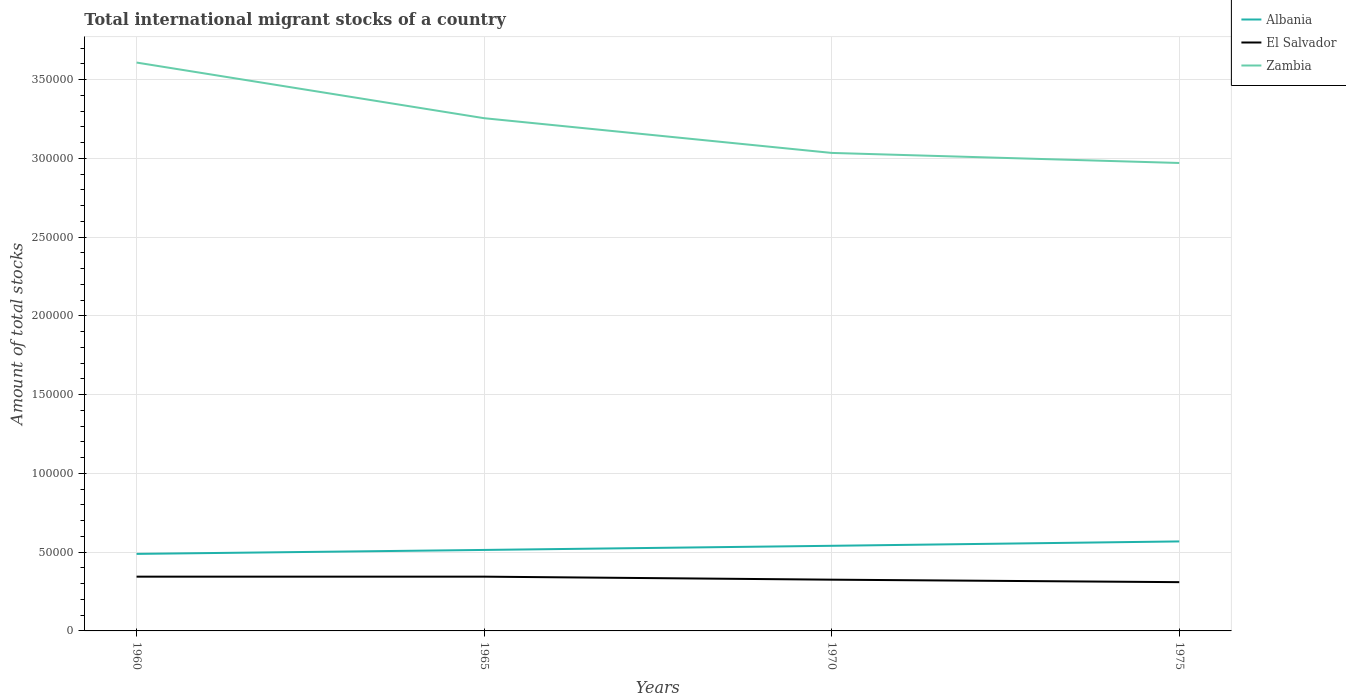How many different coloured lines are there?
Offer a terse response. 3. Does the line corresponding to Zambia intersect with the line corresponding to El Salvador?
Ensure brevity in your answer.  No. Across all years, what is the maximum amount of total stocks in in Zambia?
Offer a terse response. 2.97e+05. In which year was the amount of total stocks in in Zambia maximum?
Your response must be concise. 1975. What is the total amount of total stocks in in Zambia in the graph?
Offer a very short reply. 2.20e+04. What is the difference between the highest and the second highest amount of total stocks in in Zambia?
Offer a terse response. 6.38e+04. What is the difference between the highest and the lowest amount of total stocks in in Albania?
Make the answer very short. 2. Is the amount of total stocks in in Zambia strictly greater than the amount of total stocks in in El Salvador over the years?
Your answer should be compact. No. Does the graph contain any zero values?
Ensure brevity in your answer.  No. What is the title of the graph?
Your answer should be compact. Total international migrant stocks of a country. What is the label or title of the Y-axis?
Provide a succinct answer. Amount of total stocks. What is the Amount of total stocks in Albania in 1960?
Keep it short and to the point. 4.89e+04. What is the Amount of total stocks in El Salvador in 1960?
Provide a short and direct response. 3.44e+04. What is the Amount of total stocks of Zambia in 1960?
Your answer should be compact. 3.61e+05. What is the Amount of total stocks in Albania in 1965?
Provide a short and direct response. 5.14e+04. What is the Amount of total stocks of El Salvador in 1965?
Provide a succinct answer. 3.45e+04. What is the Amount of total stocks of Zambia in 1965?
Provide a succinct answer. 3.26e+05. What is the Amount of total stocks in Albania in 1970?
Offer a terse response. 5.40e+04. What is the Amount of total stocks of El Salvador in 1970?
Make the answer very short. 3.25e+04. What is the Amount of total stocks in Zambia in 1970?
Provide a short and direct response. 3.03e+05. What is the Amount of total stocks in Albania in 1975?
Your response must be concise. 5.68e+04. What is the Amount of total stocks in El Salvador in 1975?
Your answer should be compact. 3.10e+04. What is the Amount of total stocks of Zambia in 1975?
Ensure brevity in your answer.  2.97e+05. Across all years, what is the maximum Amount of total stocks in Albania?
Keep it short and to the point. 5.68e+04. Across all years, what is the maximum Amount of total stocks in El Salvador?
Offer a terse response. 3.45e+04. Across all years, what is the maximum Amount of total stocks in Zambia?
Your answer should be very brief. 3.61e+05. Across all years, what is the minimum Amount of total stocks in Albania?
Your response must be concise. 4.89e+04. Across all years, what is the minimum Amount of total stocks of El Salvador?
Provide a short and direct response. 3.10e+04. Across all years, what is the minimum Amount of total stocks in Zambia?
Give a very brief answer. 2.97e+05. What is the total Amount of total stocks in Albania in the graph?
Give a very brief answer. 2.11e+05. What is the total Amount of total stocks in El Salvador in the graph?
Offer a terse response. 1.32e+05. What is the total Amount of total stocks of Zambia in the graph?
Keep it short and to the point. 1.29e+06. What is the difference between the Amount of total stocks in Albania in 1960 and that in 1965?
Offer a terse response. -2508. What is the difference between the Amount of total stocks of Zambia in 1960 and that in 1965?
Make the answer very short. 3.53e+04. What is the difference between the Amount of total stocks in Albania in 1960 and that in 1970?
Make the answer very short. -5144. What is the difference between the Amount of total stocks in El Salvador in 1960 and that in 1970?
Keep it short and to the point. 1912. What is the difference between the Amount of total stocks of Zambia in 1960 and that in 1970?
Provide a short and direct response. 5.74e+04. What is the difference between the Amount of total stocks of Albania in 1960 and that in 1975?
Offer a terse response. -7915. What is the difference between the Amount of total stocks in El Salvador in 1960 and that in 1975?
Offer a very short reply. 3483. What is the difference between the Amount of total stocks of Zambia in 1960 and that in 1975?
Your answer should be compact. 6.38e+04. What is the difference between the Amount of total stocks in Albania in 1965 and that in 1970?
Make the answer very short. -2636. What is the difference between the Amount of total stocks of El Salvador in 1965 and that in 1970?
Your response must be concise. 1919. What is the difference between the Amount of total stocks of Zambia in 1965 and that in 1970?
Your answer should be compact. 2.20e+04. What is the difference between the Amount of total stocks of Albania in 1965 and that in 1975?
Offer a very short reply. -5407. What is the difference between the Amount of total stocks in El Salvador in 1965 and that in 1975?
Make the answer very short. 3490. What is the difference between the Amount of total stocks in Zambia in 1965 and that in 1975?
Your response must be concise. 2.84e+04. What is the difference between the Amount of total stocks of Albania in 1970 and that in 1975?
Your answer should be very brief. -2771. What is the difference between the Amount of total stocks of El Salvador in 1970 and that in 1975?
Make the answer very short. 1571. What is the difference between the Amount of total stocks in Zambia in 1970 and that in 1975?
Ensure brevity in your answer.  6393. What is the difference between the Amount of total stocks of Albania in 1960 and the Amount of total stocks of El Salvador in 1965?
Keep it short and to the point. 1.44e+04. What is the difference between the Amount of total stocks of Albania in 1960 and the Amount of total stocks of Zambia in 1965?
Provide a succinct answer. -2.77e+05. What is the difference between the Amount of total stocks of El Salvador in 1960 and the Amount of total stocks of Zambia in 1965?
Your response must be concise. -2.91e+05. What is the difference between the Amount of total stocks of Albania in 1960 and the Amount of total stocks of El Salvador in 1970?
Offer a very short reply. 1.64e+04. What is the difference between the Amount of total stocks in Albania in 1960 and the Amount of total stocks in Zambia in 1970?
Offer a very short reply. -2.55e+05. What is the difference between the Amount of total stocks of El Salvador in 1960 and the Amount of total stocks of Zambia in 1970?
Keep it short and to the point. -2.69e+05. What is the difference between the Amount of total stocks of Albania in 1960 and the Amount of total stocks of El Salvador in 1975?
Provide a succinct answer. 1.79e+04. What is the difference between the Amount of total stocks in Albania in 1960 and the Amount of total stocks in Zambia in 1975?
Your response must be concise. -2.48e+05. What is the difference between the Amount of total stocks of El Salvador in 1960 and the Amount of total stocks of Zambia in 1975?
Your answer should be compact. -2.63e+05. What is the difference between the Amount of total stocks in Albania in 1965 and the Amount of total stocks in El Salvador in 1970?
Offer a terse response. 1.89e+04. What is the difference between the Amount of total stocks of Albania in 1965 and the Amount of total stocks of Zambia in 1970?
Provide a succinct answer. -2.52e+05. What is the difference between the Amount of total stocks of El Salvador in 1965 and the Amount of total stocks of Zambia in 1970?
Make the answer very short. -2.69e+05. What is the difference between the Amount of total stocks of Albania in 1965 and the Amount of total stocks of El Salvador in 1975?
Offer a very short reply. 2.04e+04. What is the difference between the Amount of total stocks of Albania in 1965 and the Amount of total stocks of Zambia in 1975?
Make the answer very short. -2.46e+05. What is the difference between the Amount of total stocks in El Salvador in 1965 and the Amount of total stocks in Zambia in 1975?
Your response must be concise. -2.63e+05. What is the difference between the Amount of total stocks of Albania in 1970 and the Amount of total stocks of El Salvador in 1975?
Offer a terse response. 2.31e+04. What is the difference between the Amount of total stocks in Albania in 1970 and the Amount of total stocks in Zambia in 1975?
Keep it short and to the point. -2.43e+05. What is the difference between the Amount of total stocks in El Salvador in 1970 and the Amount of total stocks in Zambia in 1975?
Ensure brevity in your answer.  -2.65e+05. What is the average Amount of total stocks of Albania per year?
Your response must be concise. 5.28e+04. What is the average Amount of total stocks of El Salvador per year?
Your answer should be very brief. 3.31e+04. What is the average Amount of total stocks of Zambia per year?
Provide a short and direct response. 3.22e+05. In the year 1960, what is the difference between the Amount of total stocks in Albania and Amount of total stocks in El Salvador?
Offer a terse response. 1.45e+04. In the year 1960, what is the difference between the Amount of total stocks of Albania and Amount of total stocks of Zambia?
Your answer should be very brief. -3.12e+05. In the year 1960, what is the difference between the Amount of total stocks of El Salvador and Amount of total stocks of Zambia?
Offer a very short reply. -3.26e+05. In the year 1965, what is the difference between the Amount of total stocks in Albania and Amount of total stocks in El Salvador?
Make the answer very short. 1.70e+04. In the year 1965, what is the difference between the Amount of total stocks of Albania and Amount of total stocks of Zambia?
Offer a very short reply. -2.74e+05. In the year 1965, what is the difference between the Amount of total stocks in El Salvador and Amount of total stocks in Zambia?
Your answer should be compact. -2.91e+05. In the year 1970, what is the difference between the Amount of total stocks of Albania and Amount of total stocks of El Salvador?
Offer a terse response. 2.15e+04. In the year 1970, what is the difference between the Amount of total stocks in Albania and Amount of total stocks in Zambia?
Your response must be concise. -2.49e+05. In the year 1970, what is the difference between the Amount of total stocks in El Salvador and Amount of total stocks in Zambia?
Your answer should be compact. -2.71e+05. In the year 1975, what is the difference between the Amount of total stocks in Albania and Amount of total stocks in El Salvador?
Keep it short and to the point. 2.59e+04. In the year 1975, what is the difference between the Amount of total stocks in Albania and Amount of total stocks in Zambia?
Your answer should be compact. -2.40e+05. In the year 1975, what is the difference between the Amount of total stocks in El Salvador and Amount of total stocks in Zambia?
Provide a succinct answer. -2.66e+05. What is the ratio of the Amount of total stocks in Albania in 1960 to that in 1965?
Your answer should be very brief. 0.95. What is the ratio of the Amount of total stocks of Zambia in 1960 to that in 1965?
Your answer should be compact. 1.11. What is the ratio of the Amount of total stocks in Albania in 1960 to that in 1970?
Ensure brevity in your answer.  0.9. What is the ratio of the Amount of total stocks in El Salvador in 1960 to that in 1970?
Your answer should be compact. 1.06. What is the ratio of the Amount of total stocks in Zambia in 1960 to that in 1970?
Give a very brief answer. 1.19. What is the ratio of the Amount of total stocks in Albania in 1960 to that in 1975?
Ensure brevity in your answer.  0.86. What is the ratio of the Amount of total stocks of El Salvador in 1960 to that in 1975?
Offer a terse response. 1.11. What is the ratio of the Amount of total stocks in Zambia in 1960 to that in 1975?
Your response must be concise. 1.21. What is the ratio of the Amount of total stocks in Albania in 1965 to that in 1970?
Offer a terse response. 0.95. What is the ratio of the Amount of total stocks in El Salvador in 1965 to that in 1970?
Provide a succinct answer. 1.06. What is the ratio of the Amount of total stocks in Zambia in 1965 to that in 1970?
Ensure brevity in your answer.  1.07. What is the ratio of the Amount of total stocks in Albania in 1965 to that in 1975?
Give a very brief answer. 0.9. What is the ratio of the Amount of total stocks of El Salvador in 1965 to that in 1975?
Provide a succinct answer. 1.11. What is the ratio of the Amount of total stocks in Zambia in 1965 to that in 1975?
Ensure brevity in your answer.  1.1. What is the ratio of the Amount of total stocks in Albania in 1970 to that in 1975?
Your answer should be compact. 0.95. What is the ratio of the Amount of total stocks of El Salvador in 1970 to that in 1975?
Your answer should be compact. 1.05. What is the ratio of the Amount of total stocks in Zambia in 1970 to that in 1975?
Your response must be concise. 1.02. What is the difference between the highest and the second highest Amount of total stocks of Albania?
Your answer should be compact. 2771. What is the difference between the highest and the second highest Amount of total stocks in Zambia?
Keep it short and to the point. 3.53e+04. What is the difference between the highest and the lowest Amount of total stocks in Albania?
Keep it short and to the point. 7915. What is the difference between the highest and the lowest Amount of total stocks in El Salvador?
Provide a short and direct response. 3490. What is the difference between the highest and the lowest Amount of total stocks of Zambia?
Keep it short and to the point. 6.38e+04. 